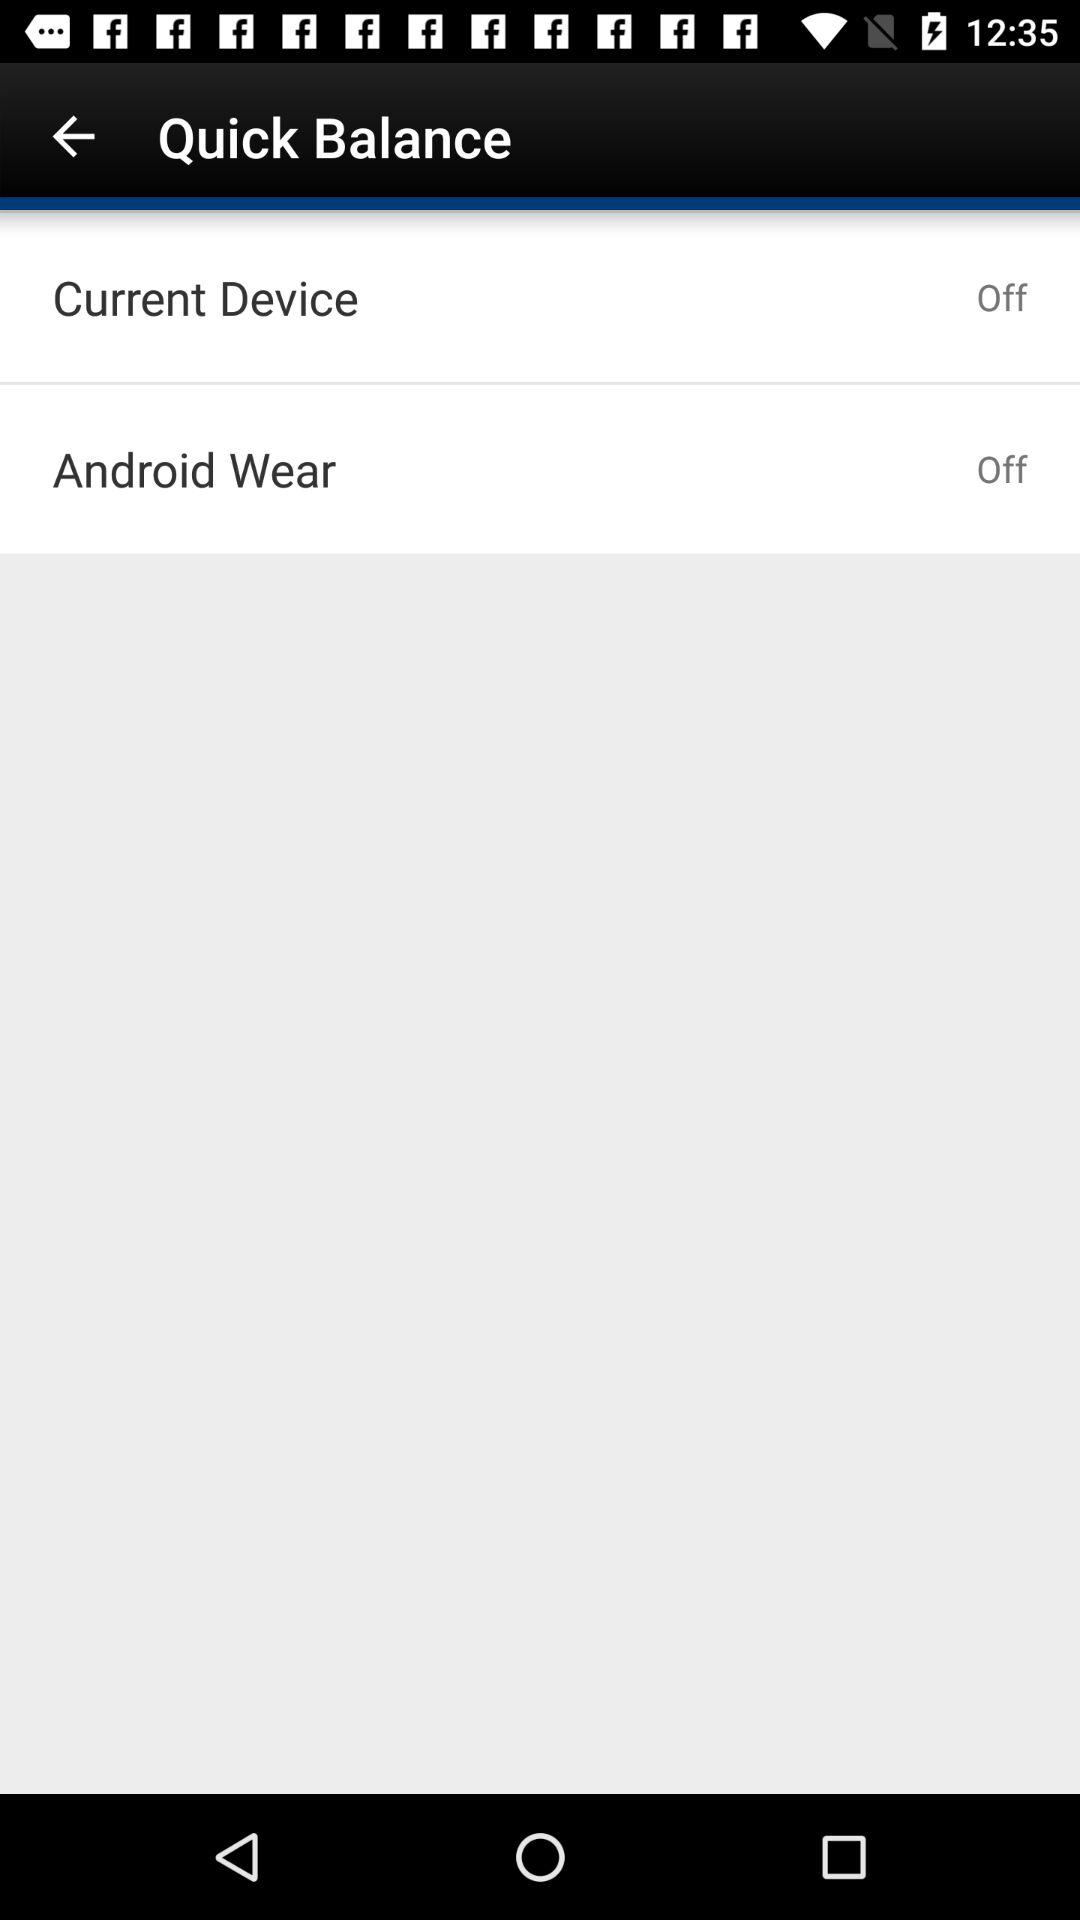How many devices are turned off?
Answer the question using a single word or phrase. 2 